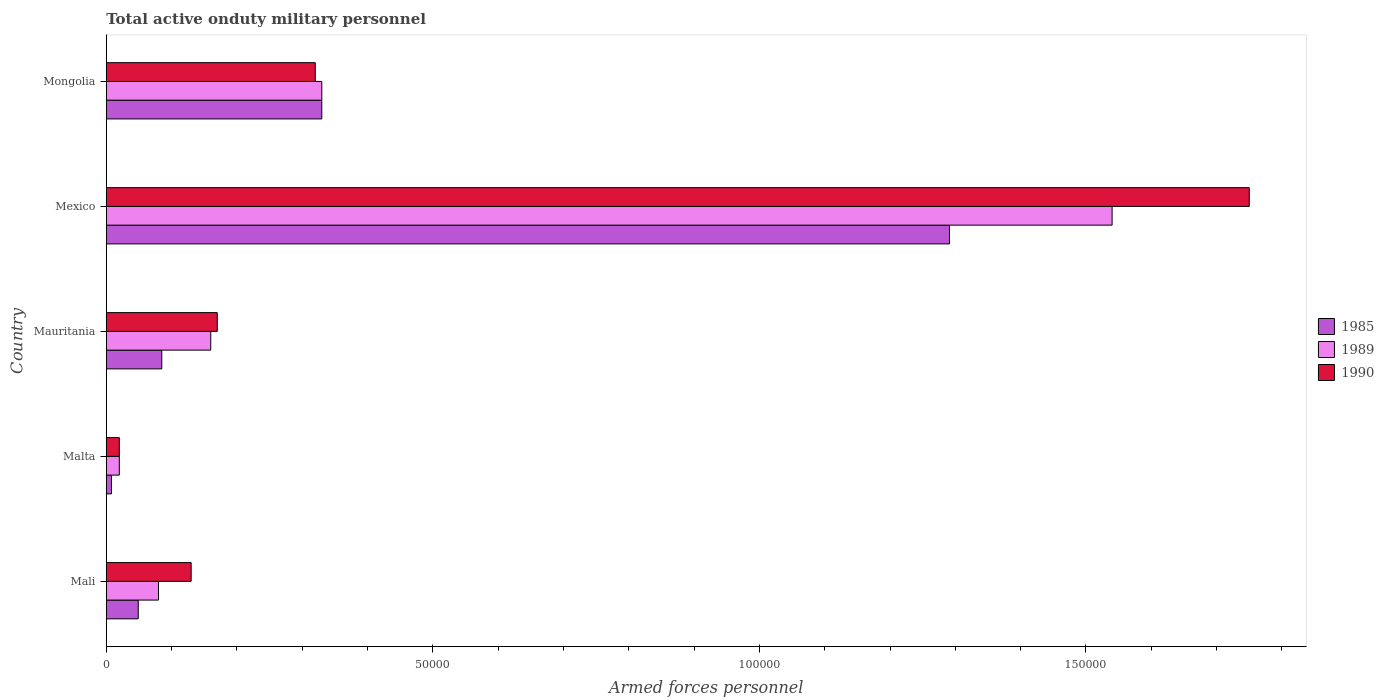How many different coloured bars are there?
Keep it short and to the point. 3. Are the number of bars on each tick of the Y-axis equal?
Keep it short and to the point. Yes. How many bars are there on the 4th tick from the top?
Ensure brevity in your answer.  3. How many bars are there on the 2nd tick from the bottom?
Offer a very short reply. 3. What is the label of the 3rd group of bars from the top?
Make the answer very short. Mauritania. In how many cases, is the number of bars for a given country not equal to the number of legend labels?
Make the answer very short. 0. What is the number of armed forces personnel in 1989 in Malta?
Your answer should be compact. 2000. Across all countries, what is the maximum number of armed forces personnel in 1989?
Offer a very short reply. 1.54e+05. In which country was the number of armed forces personnel in 1989 maximum?
Provide a short and direct response. Mexico. In which country was the number of armed forces personnel in 1989 minimum?
Make the answer very short. Malta. What is the total number of armed forces personnel in 1989 in the graph?
Keep it short and to the point. 2.13e+05. What is the difference between the number of armed forces personnel in 1990 in Malta and that in Mexico?
Your answer should be very brief. -1.73e+05. What is the average number of armed forces personnel in 1990 per country?
Offer a terse response. 4.78e+04. What is the difference between the number of armed forces personnel in 1989 and number of armed forces personnel in 1990 in Mongolia?
Provide a succinct answer. 1000. What is the ratio of the number of armed forces personnel in 1985 in Mali to that in Mongolia?
Offer a terse response. 0.15. What is the difference between the highest and the second highest number of armed forces personnel in 1990?
Your response must be concise. 1.43e+05. What is the difference between the highest and the lowest number of armed forces personnel in 1989?
Offer a terse response. 1.52e+05. Are all the bars in the graph horizontal?
Provide a short and direct response. Yes. Does the graph contain any zero values?
Make the answer very short. No. Where does the legend appear in the graph?
Ensure brevity in your answer.  Center right. What is the title of the graph?
Keep it short and to the point. Total active onduty military personnel. Does "2000" appear as one of the legend labels in the graph?
Give a very brief answer. No. What is the label or title of the X-axis?
Provide a succinct answer. Armed forces personnel. What is the label or title of the Y-axis?
Offer a very short reply. Country. What is the Armed forces personnel in 1985 in Mali?
Your response must be concise. 4900. What is the Armed forces personnel of 1989 in Mali?
Give a very brief answer. 8000. What is the Armed forces personnel in 1990 in Mali?
Ensure brevity in your answer.  1.30e+04. What is the Armed forces personnel of 1985 in Malta?
Provide a succinct answer. 800. What is the Armed forces personnel in 1989 in Malta?
Provide a succinct answer. 2000. What is the Armed forces personnel of 1985 in Mauritania?
Your response must be concise. 8500. What is the Armed forces personnel of 1989 in Mauritania?
Make the answer very short. 1.60e+04. What is the Armed forces personnel of 1990 in Mauritania?
Offer a very short reply. 1.70e+04. What is the Armed forces personnel of 1985 in Mexico?
Provide a succinct answer. 1.29e+05. What is the Armed forces personnel in 1989 in Mexico?
Keep it short and to the point. 1.54e+05. What is the Armed forces personnel of 1990 in Mexico?
Your response must be concise. 1.75e+05. What is the Armed forces personnel of 1985 in Mongolia?
Your answer should be compact. 3.30e+04. What is the Armed forces personnel in 1989 in Mongolia?
Make the answer very short. 3.30e+04. What is the Armed forces personnel of 1990 in Mongolia?
Your response must be concise. 3.20e+04. Across all countries, what is the maximum Armed forces personnel of 1985?
Ensure brevity in your answer.  1.29e+05. Across all countries, what is the maximum Armed forces personnel of 1989?
Your response must be concise. 1.54e+05. Across all countries, what is the maximum Armed forces personnel in 1990?
Ensure brevity in your answer.  1.75e+05. Across all countries, what is the minimum Armed forces personnel of 1985?
Provide a succinct answer. 800. Across all countries, what is the minimum Armed forces personnel in 1989?
Keep it short and to the point. 2000. Across all countries, what is the minimum Armed forces personnel of 1990?
Ensure brevity in your answer.  2000. What is the total Armed forces personnel in 1985 in the graph?
Offer a very short reply. 1.76e+05. What is the total Armed forces personnel of 1989 in the graph?
Ensure brevity in your answer.  2.13e+05. What is the total Armed forces personnel of 1990 in the graph?
Provide a short and direct response. 2.39e+05. What is the difference between the Armed forces personnel in 1985 in Mali and that in Malta?
Keep it short and to the point. 4100. What is the difference between the Armed forces personnel of 1989 in Mali and that in Malta?
Provide a short and direct response. 6000. What is the difference between the Armed forces personnel in 1990 in Mali and that in Malta?
Your answer should be very brief. 1.10e+04. What is the difference between the Armed forces personnel of 1985 in Mali and that in Mauritania?
Make the answer very short. -3600. What is the difference between the Armed forces personnel of 1989 in Mali and that in Mauritania?
Ensure brevity in your answer.  -8000. What is the difference between the Armed forces personnel of 1990 in Mali and that in Mauritania?
Your answer should be compact. -4000. What is the difference between the Armed forces personnel of 1985 in Mali and that in Mexico?
Ensure brevity in your answer.  -1.24e+05. What is the difference between the Armed forces personnel of 1989 in Mali and that in Mexico?
Keep it short and to the point. -1.46e+05. What is the difference between the Armed forces personnel of 1990 in Mali and that in Mexico?
Make the answer very short. -1.62e+05. What is the difference between the Armed forces personnel in 1985 in Mali and that in Mongolia?
Your answer should be compact. -2.81e+04. What is the difference between the Armed forces personnel of 1989 in Mali and that in Mongolia?
Your response must be concise. -2.50e+04. What is the difference between the Armed forces personnel of 1990 in Mali and that in Mongolia?
Provide a succinct answer. -1.90e+04. What is the difference between the Armed forces personnel of 1985 in Malta and that in Mauritania?
Provide a succinct answer. -7700. What is the difference between the Armed forces personnel in 1989 in Malta and that in Mauritania?
Provide a succinct answer. -1.40e+04. What is the difference between the Armed forces personnel of 1990 in Malta and that in Mauritania?
Provide a succinct answer. -1.50e+04. What is the difference between the Armed forces personnel of 1985 in Malta and that in Mexico?
Provide a succinct answer. -1.28e+05. What is the difference between the Armed forces personnel of 1989 in Malta and that in Mexico?
Offer a very short reply. -1.52e+05. What is the difference between the Armed forces personnel of 1990 in Malta and that in Mexico?
Keep it short and to the point. -1.73e+05. What is the difference between the Armed forces personnel of 1985 in Malta and that in Mongolia?
Provide a short and direct response. -3.22e+04. What is the difference between the Armed forces personnel of 1989 in Malta and that in Mongolia?
Keep it short and to the point. -3.10e+04. What is the difference between the Armed forces personnel in 1990 in Malta and that in Mongolia?
Give a very brief answer. -3.00e+04. What is the difference between the Armed forces personnel in 1985 in Mauritania and that in Mexico?
Ensure brevity in your answer.  -1.21e+05. What is the difference between the Armed forces personnel of 1989 in Mauritania and that in Mexico?
Your answer should be compact. -1.38e+05. What is the difference between the Armed forces personnel of 1990 in Mauritania and that in Mexico?
Offer a terse response. -1.58e+05. What is the difference between the Armed forces personnel in 1985 in Mauritania and that in Mongolia?
Provide a short and direct response. -2.45e+04. What is the difference between the Armed forces personnel of 1989 in Mauritania and that in Mongolia?
Offer a very short reply. -1.70e+04. What is the difference between the Armed forces personnel in 1990 in Mauritania and that in Mongolia?
Offer a very short reply. -1.50e+04. What is the difference between the Armed forces personnel of 1985 in Mexico and that in Mongolia?
Provide a succinct answer. 9.61e+04. What is the difference between the Armed forces personnel in 1989 in Mexico and that in Mongolia?
Your answer should be compact. 1.21e+05. What is the difference between the Armed forces personnel of 1990 in Mexico and that in Mongolia?
Keep it short and to the point. 1.43e+05. What is the difference between the Armed forces personnel in 1985 in Mali and the Armed forces personnel in 1989 in Malta?
Make the answer very short. 2900. What is the difference between the Armed forces personnel in 1985 in Mali and the Armed forces personnel in 1990 in Malta?
Provide a short and direct response. 2900. What is the difference between the Armed forces personnel of 1989 in Mali and the Armed forces personnel of 1990 in Malta?
Provide a succinct answer. 6000. What is the difference between the Armed forces personnel of 1985 in Mali and the Armed forces personnel of 1989 in Mauritania?
Provide a short and direct response. -1.11e+04. What is the difference between the Armed forces personnel of 1985 in Mali and the Armed forces personnel of 1990 in Mauritania?
Keep it short and to the point. -1.21e+04. What is the difference between the Armed forces personnel of 1989 in Mali and the Armed forces personnel of 1990 in Mauritania?
Your answer should be very brief. -9000. What is the difference between the Armed forces personnel in 1985 in Mali and the Armed forces personnel in 1989 in Mexico?
Provide a short and direct response. -1.49e+05. What is the difference between the Armed forces personnel of 1985 in Mali and the Armed forces personnel of 1990 in Mexico?
Provide a succinct answer. -1.70e+05. What is the difference between the Armed forces personnel in 1989 in Mali and the Armed forces personnel in 1990 in Mexico?
Offer a very short reply. -1.67e+05. What is the difference between the Armed forces personnel of 1985 in Mali and the Armed forces personnel of 1989 in Mongolia?
Your answer should be compact. -2.81e+04. What is the difference between the Armed forces personnel in 1985 in Mali and the Armed forces personnel in 1990 in Mongolia?
Keep it short and to the point. -2.71e+04. What is the difference between the Armed forces personnel of 1989 in Mali and the Armed forces personnel of 1990 in Mongolia?
Your answer should be compact. -2.40e+04. What is the difference between the Armed forces personnel of 1985 in Malta and the Armed forces personnel of 1989 in Mauritania?
Provide a short and direct response. -1.52e+04. What is the difference between the Armed forces personnel in 1985 in Malta and the Armed forces personnel in 1990 in Mauritania?
Offer a very short reply. -1.62e+04. What is the difference between the Armed forces personnel in 1989 in Malta and the Armed forces personnel in 1990 in Mauritania?
Offer a terse response. -1.50e+04. What is the difference between the Armed forces personnel of 1985 in Malta and the Armed forces personnel of 1989 in Mexico?
Your answer should be very brief. -1.53e+05. What is the difference between the Armed forces personnel of 1985 in Malta and the Armed forces personnel of 1990 in Mexico?
Give a very brief answer. -1.74e+05. What is the difference between the Armed forces personnel of 1989 in Malta and the Armed forces personnel of 1990 in Mexico?
Ensure brevity in your answer.  -1.73e+05. What is the difference between the Armed forces personnel of 1985 in Malta and the Armed forces personnel of 1989 in Mongolia?
Offer a terse response. -3.22e+04. What is the difference between the Armed forces personnel of 1985 in Malta and the Armed forces personnel of 1990 in Mongolia?
Your answer should be compact. -3.12e+04. What is the difference between the Armed forces personnel in 1989 in Malta and the Armed forces personnel in 1990 in Mongolia?
Provide a short and direct response. -3.00e+04. What is the difference between the Armed forces personnel in 1985 in Mauritania and the Armed forces personnel in 1989 in Mexico?
Make the answer very short. -1.46e+05. What is the difference between the Armed forces personnel of 1985 in Mauritania and the Armed forces personnel of 1990 in Mexico?
Your answer should be compact. -1.66e+05. What is the difference between the Armed forces personnel in 1989 in Mauritania and the Armed forces personnel in 1990 in Mexico?
Offer a very short reply. -1.59e+05. What is the difference between the Armed forces personnel in 1985 in Mauritania and the Armed forces personnel in 1989 in Mongolia?
Your response must be concise. -2.45e+04. What is the difference between the Armed forces personnel of 1985 in Mauritania and the Armed forces personnel of 1990 in Mongolia?
Keep it short and to the point. -2.35e+04. What is the difference between the Armed forces personnel of 1989 in Mauritania and the Armed forces personnel of 1990 in Mongolia?
Make the answer very short. -1.60e+04. What is the difference between the Armed forces personnel of 1985 in Mexico and the Armed forces personnel of 1989 in Mongolia?
Make the answer very short. 9.61e+04. What is the difference between the Armed forces personnel in 1985 in Mexico and the Armed forces personnel in 1990 in Mongolia?
Give a very brief answer. 9.71e+04. What is the difference between the Armed forces personnel in 1989 in Mexico and the Armed forces personnel in 1990 in Mongolia?
Offer a very short reply. 1.22e+05. What is the average Armed forces personnel of 1985 per country?
Make the answer very short. 3.53e+04. What is the average Armed forces personnel in 1989 per country?
Give a very brief answer. 4.26e+04. What is the average Armed forces personnel of 1990 per country?
Your answer should be very brief. 4.78e+04. What is the difference between the Armed forces personnel in 1985 and Armed forces personnel in 1989 in Mali?
Give a very brief answer. -3100. What is the difference between the Armed forces personnel of 1985 and Armed forces personnel of 1990 in Mali?
Your response must be concise. -8100. What is the difference between the Armed forces personnel of 1989 and Armed forces personnel of 1990 in Mali?
Offer a very short reply. -5000. What is the difference between the Armed forces personnel in 1985 and Armed forces personnel in 1989 in Malta?
Your response must be concise. -1200. What is the difference between the Armed forces personnel in 1985 and Armed forces personnel in 1990 in Malta?
Make the answer very short. -1200. What is the difference between the Armed forces personnel of 1989 and Armed forces personnel of 1990 in Malta?
Offer a very short reply. 0. What is the difference between the Armed forces personnel of 1985 and Armed forces personnel of 1989 in Mauritania?
Give a very brief answer. -7500. What is the difference between the Armed forces personnel in 1985 and Armed forces personnel in 1990 in Mauritania?
Offer a very short reply. -8500. What is the difference between the Armed forces personnel in 1989 and Armed forces personnel in 1990 in Mauritania?
Keep it short and to the point. -1000. What is the difference between the Armed forces personnel in 1985 and Armed forces personnel in 1989 in Mexico?
Your answer should be very brief. -2.49e+04. What is the difference between the Armed forces personnel of 1985 and Armed forces personnel of 1990 in Mexico?
Your answer should be very brief. -4.59e+04. What is the difference between the Armed forces personnel in 1989 and Armed forces personnel in 1990 in Mexico?
Your response must be concise. -2.10e+04. What is the difference between the Armed forces personnel in 1985 and Armed forces personnel in 1989 in Mongolia?
Your answer should be very brief. 0. What is the difference between the Armed forces personnel in 1989 and Armed forces personnel in 1990 in Mongolia?
Make the answer very short. 1000. What is the ratio of the Armed forces personnel of 1985 in Mali to that in Malta?
Your answer should be very brief. 6.12. What is the ratio of the Armed forces personnel in 1989 in Mali to that in Malta?
Your response must be concise. 4. What is the ratio of the Armed forces personnel of 1990 in Mali to that in Malta?
Provide a short and direct response. 6.5. What is the ratio of the Armed forces personnel in 1985 in Mali to that in Mauritania?
Your answer should be compact. 0.58. What is the ratio of the Armed forces personnel of 1990 in Mali to that in Mauritania?
Your answer should be very brief. 0.76. What is the ratio of the Armed forces personnel in 1985 in Mali to that in Mexico?
Offer a very short reply. 0.04. What is the ratio of the Armed forces personnel in 1989 in Mali to that in Mexico?
Provide a succinct answer. 0.05. What is the ratio of the Armed forces personnel in 1990 in Mali to that in Mexico?
Provide a short and direct response. 0.07. What is the ratio of the Armed forces personnel of 1985 in Mali to that in Mongolia?
Provide a short and direct response. 0.15. What is the ratio of the Armed forces personnel in 1989 in Mali to that in Mongolia?
Make the answer very short. 0.24. What is the ratio of the Armed forces personnel of 1990 in Mali to that in Mongolia?
Offer a terse response. 0.41. What is the ratio of the Armed forces personnel of 1985 in Malta to that in Mauritania?
Give a very brief answer. 0.09. What is the ratio of the Armed forces personnel of 1989 in Malta to that in Mauritania?
Make the answer very short. 0.12. What is the ratio of the Armed forces personnel in 1990 in Malta to that in Mauritania?
Give a very brief answer. 0.12. What is the ratio of the Armed forces personnel of 1985 in Malta to that in Mexico?
Provide a short and direct response. 0.01. What is the ratio of the Armed forces personnel of 1989 in Malta to that in Mexico?
Provide a short and direct response. 0.01. What is the ratio of the Armed forces personnel in 1990 in Malta to that in Mexico?
Provide a succinct answer. 0.01. What is the ratio of the Armed forces personnel in 1985 in Malta to that in Mongolia?
Keep it short and to the point. 0.02. What is the ratio of the Armed forces personnel of 1989 in Malta to that in Mongolia?
Offer a terse response. 0.06. What is the ratio of the Armed forces personnel of 1990 in Malta to that in Mongolia?
Provide a succinct answer. 0.06. What is the ratio of the Armed forces personnel in 1985 in Mauritania to that in Mexico?
Offer a very short reply. 0.07. What is the ratio of the Armed forces personnel of 1989 in Mauritania to that in Mexico?
Provide a succinct answer. 0.1. What is the ratio of the Armed forces personnel of 1990 in Mauritania to that in Mexico?
Give a very brief answer. 0.1. What is the ratio of the Armed forces personnel in 1985 in Mauritania to that in Mongolia?
Provide a short and direct response. 0.26. What is the ratio of the Armed forces personnel in 1989 in Mauritania to that in Mongolia?
Your response must be concise. 0.48. What is the ratio of the Armed forces personnel in 1990 in Mauritania to that in Mongolia?
Ensure brevity in your answer.  0.53. What is the ratio of the Armed forces personnel in 1985 in Mexico to that in Mongolia?
Offer a very short reply. 3.91. What is the ratio of the Armed forces personnel of 1989 in Mexico to that in Mongolia?
Give a very brief answer. 4.67. What is the ratio of the Armed forces personnel in 1990 in Mexico to that in Mongolia?
Ensure brevity in your answer.  5.47. What is the difference between the highest and the second highest Armed forces personnel in 1985?
Your response must be concise. 9.61e+04. What is the difference between the highest and the second highest Armed forces personnel in 1989?
Make the answer very short. 1.21e+05. What is the difference between the highest and the second highest Armed forces personnel of 1990?
Ensure brevity in your answer.  1.43e+05. What is the difference between the highest and the lowest Armed forces personnel in 1985?
Your answer should be compact. 1.28e+05. What is the difference between the highest and the lowest Armed forces personnel in 1989?
Keep it short and to the point. 1.52e+05. What is the difference between the highest and the lowest Armed forces personnel of 1990?
Offer a very short reply. 1.73e+05. 